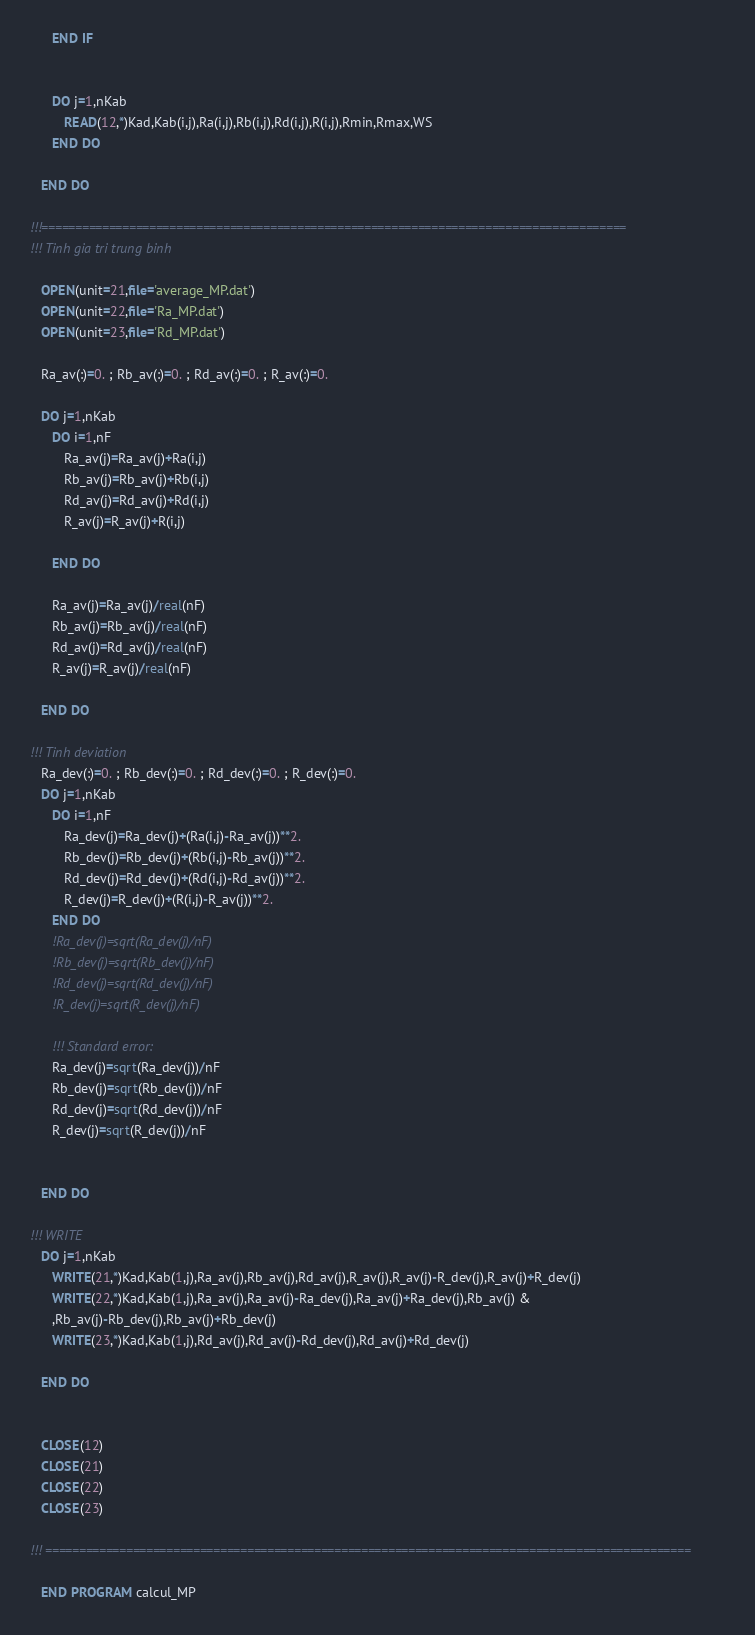Convert code to text. <code><loc_0><loc_0><loc_500><loc_500><_FORTRAN_>      END IF
      
      
      DO j=1,nKab
         READ(12,*)Kad,Kab(i,j),Ra(i,j),Rb(i,j),Rd(i,j),R(i,j),Rmin,Rmax,WS
      END DO     
                  
   END DO 
                 
!!!=======================================================================================
!!! Tinh gia tri trung binh

   OPEN(unit=21,file='average_MP.dat')  
   OPEN(unit=22,file='Ra_MP.dat')     
   OPEN(unit=23,file='Rd_MP.dat') 
       
   Ra_av(:)=0. ; Rb_av(:)=0. ; Rd_av(:)=0. ; R_av(:)=0.
 
   DO j=1,nKab
      DO i=1,nF
         Ra_av(j)=Ra_av(j)+Ra(i,j)
         Rb_av(j)=Rb_av(j)+Rb(i,j)
         Rd_av(j)=Rd_av(j)+Rd(i,j)
         R_av(j)=R_av(j)+R(i,j)
                
      END DO
      
      Ra_av(j)=Ra_av(j)/real(nF)
      Rb_av(j)=Rb_av(j)/real(nF)
      Rd_av(j)=Rd_av(j)/real(nF)
      R_av(j)=R_av(j)/real(nF)
      
   END DO

!!! Tinh deviation        
   Ra_dev(:)=0. ; Rb_dev(:)=0. ; Rd_dev(:)=0. ; R_dev(:)=0.
   DO j=1,nKab
      DO i=1,nF
         Ra_dev(j)=Ra_dev(j)+(Ra(i,j)-Ra_av(j))**2.
         Rb_dev(j)=Rb_dev(j)+(Rb(i,j)-Rb_av(j))**2.
         Rd_dev(j)=Rd_dev(j)+(Rd(i,j)-Rd_av(j))**2.
         R_dev(j)=R_dev(j)+(R(i,j)-R_av(j))**2.
      END DO
      !Ra_dev(j)=sqrt(Ra_dev(j)/nF)
      !Rb_dev(j)=sqrt(Rb_dev(j)/nF)
      !Rd_dev(j)=sqrt(Rd_dev(j)/nF)
      !R_dev(j)=sqrt(R_dev(j)/nF)
      
      !!! Standard error:
      Ra_dev(j)=sqrt(Ra_dev(j))/nF
      Rb_dev(j)=sqrt(Rb_dev(j))/nF
      Rd_dev(j)=sqrt(Rd_dev(j))/nF
      R_dev(j)=sqrt(R_dev(j))/nF
      
      
   END DO        

!!! WRITE         
   DO j=1,nKab
      WRITE(21,*)Kad,Kab(1,j),Ra_av(j),Rb_av(j),Rd_av(j),R_av(j),R_av(j)-R_dev(j),R_av(j)+R_dev(j)
      WRITE(22,*)Kad,Kab(1,j),Ra_av(j),Ra_av(j)-Ra_dev(j),Ra_av(j)+Ra_dev(j),Rb_av(j) &
      ,Rb_av(j)-Rb_dev(j),Rb_av(j)+Rb_dev(j)
      WRITE(23,*)Kad,Kab(1,j),Rd_av(j),Rd_av(j)-Rd_dev(j),Rd_av(j)+Rd_dev(j)
      
   END DO
         
         
   CLOSE(12)
   CLOSE(21) 
   CLOSE(22)
   CLOSE(23)

!!! ================================================================================================
      
   END PROGRAM calcul_MP


</code> 